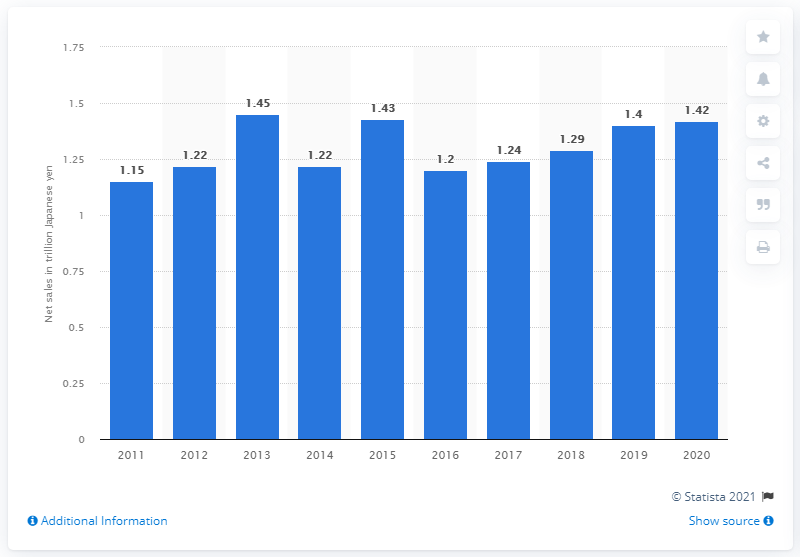Draw attention to some important aspects in this diagram. The net sales of Otsuka Holdings Co., Ltd. in the previous year were 1.4 billion yen. The net sales of Otsuka Holdings Co., Ltd. in 2020 was 1,420,000. 